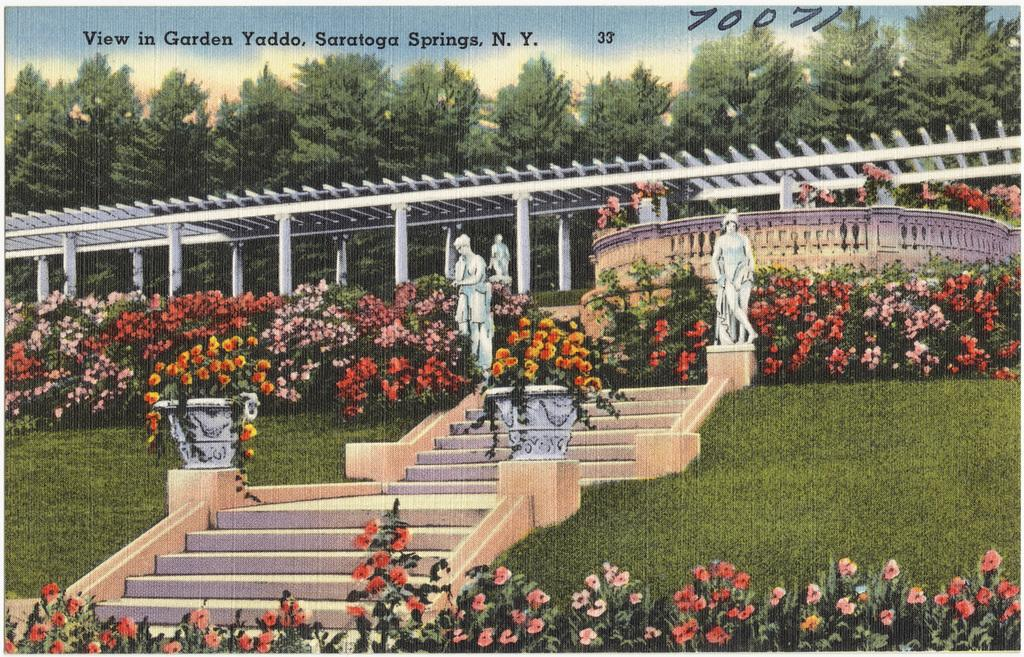<image>
Give a short and clear explanation of the subsequent image. A picture of Garden Yaddo, in Saratoga Springs in New York. 